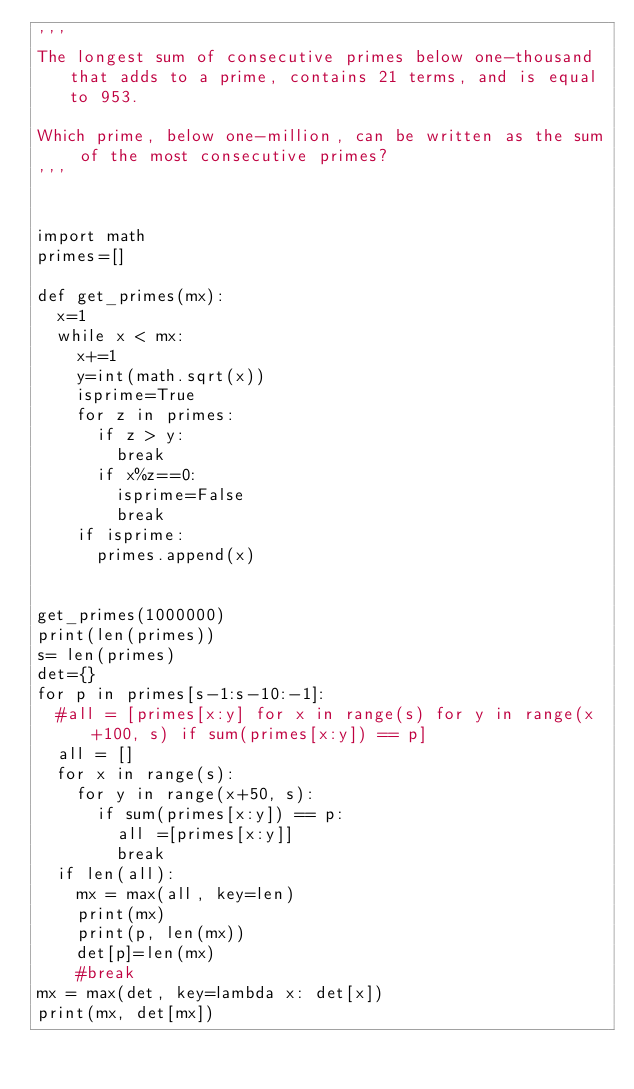<code> <loc_0><loc_0><loc_500><loc_500><_Python_>'''
The longest sum of consecutive primes below one-thousand that adds to a prime, contains 21 terms, and is equal to 953.

Which prime, below one-million, can be written as the sum of the most consecutive primes?
'''


import math
primes=[]

def get_primes(mx):
	x=1
	while x < mx:
		x+=1
		y=int(math.sqrt(x))
		isprime=True
		for z in primes:
			if z > y:
				break
			if x%z==0:
				isprime=False
				break
		if isprime:
			primes.append(x)
			
			
get_primes(1000000)
print(len(primes))
s= len(primes)
det={}
for p in primes[s-1:s-10:-1]:
	#all = [primes[x:y] for x in range(s) for y in range(x+100, s) if sum(primes[x:y]) == p]
	all = []
	for x in range(s):
		for y in range(x+50, s):
			if sum(primes[x:y]) == p:
				all =[primes[x:y]]
				break
	if len(all):
		mx = max(all, key=len)
		print(mx)
		print(p, len(mx))
		det[p]=len(mx)
		#break
mx = max(det, key=lambda x: det[x])
print(mx, det[mx])

	</code> 